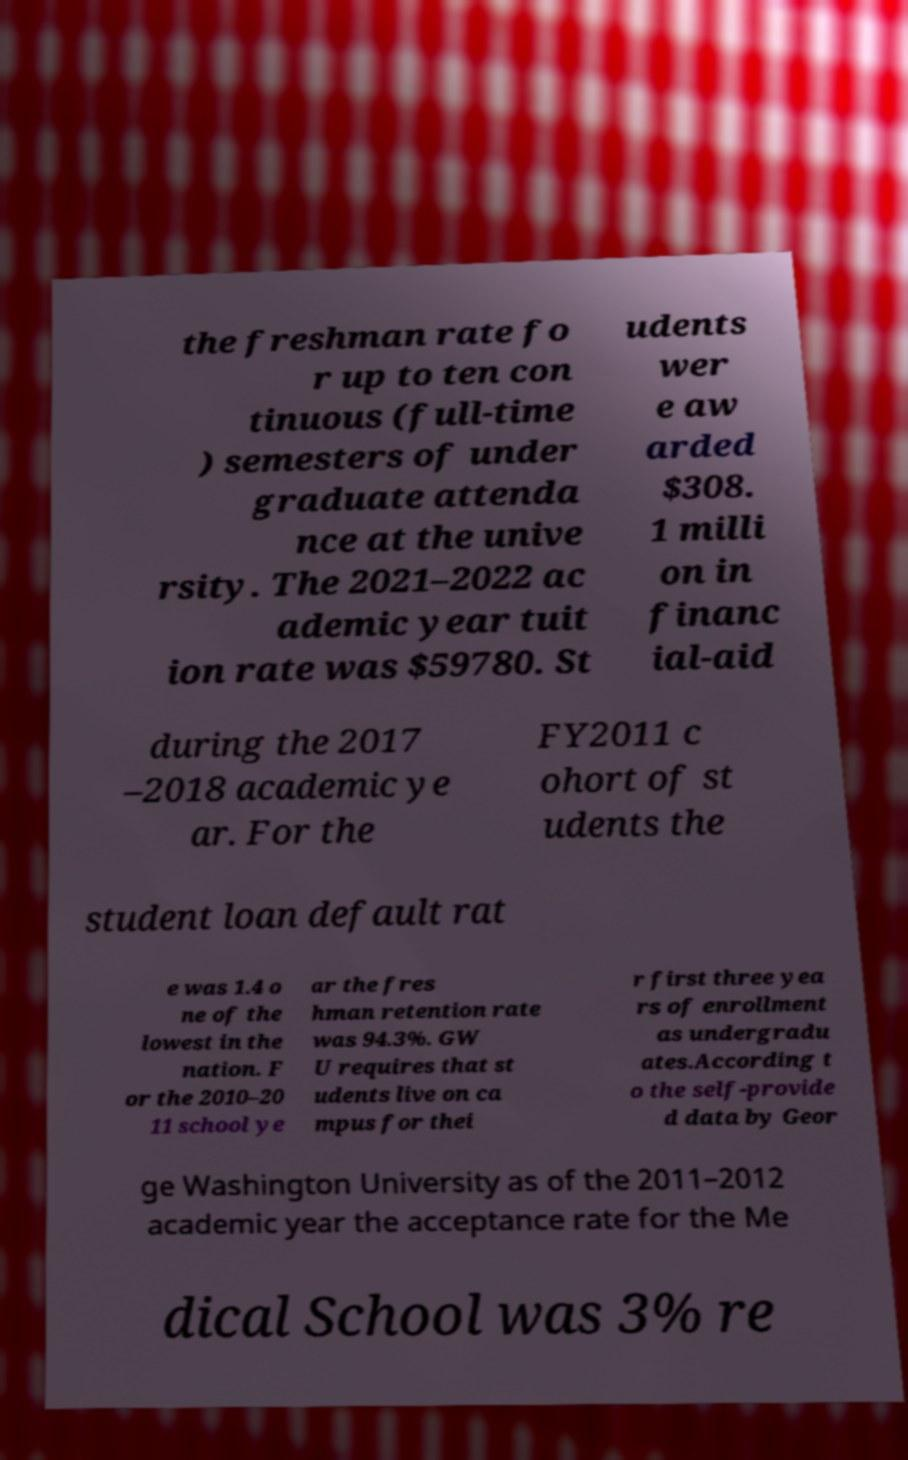Can you accurately transcribe the text from the provided image for me? the freshman rate fo r up to ten con tinuous (full-time ) semesters of under graduate attenda nce at the unive rsity. The 2021–2022 ac ademic year tuit ion rate was $59780. St udents wer e aw arded $308. 1 milli on in financ ial-aid during the 2017 –2018 academic ye ar. For the FY2011 c ohort of st udents the student loan default rat e was 1.4 o ne of the lowest in the nation. F or the 2010–20 11 school ye ar the fres hman retention rate was 94.3%. GW U requires that st udents live on ca mpus for thei r first three yea rs of enrollment as undergradu ates.According t o the self-provide d data by Geor ge Washington University as of the 2011–2012 academic year the acceptance rate for the Me dical School was 3% re 